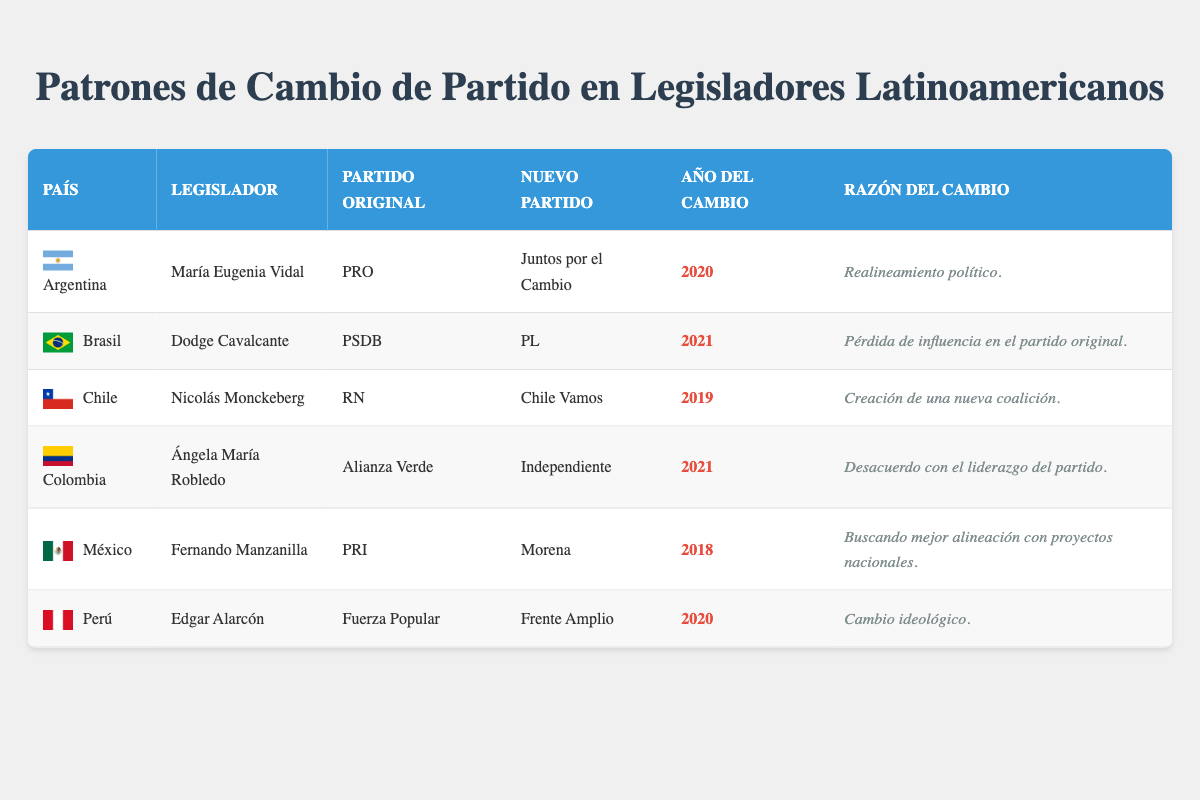What country did María Eugenia Vidal switch parties in? According to the table, María Eugenia Vidal switched parties in Argentina.
Answer: Argentina In what year did Fernando Manzanilla change parties? The table indicates that Fernando Manzanilla changed parties in the year 2018.
Answer: 2018 Which legislator switched from Alianza Verde to Independiente? From the data in the table, the legislator who switched from Alianza Verde to Independiente is Ángela María Robledo.
Answer: Ángela María Robledo How many legislators switched parties for reasons related to political realignment? There is only one legislator, María Eugenia Vidal, who switched parties for the reason of political realignment, as noted in the "reason for switch" column.
Answer: 1 Was Nicolás Monckeberg's switch related to disagreement with party leadership? The table states that Nicolás Monckeberg's switch was due to the creation of a new coalition, not disagreement with party leadership. Thus, the answer is no.
Answer: No What is the average year of party switch among the listed legislators? To find the average year, we add the years of switch (2020, 2021, 2019, 2021, 2018, 2020 = 2019) and divide by the number of legislators (6): (2020 + 2021 + 2019 + 2021 + 2018 + 2020) / 6 = 2019.
Answer: 2019 Which party did Dodge Cavalcante join after leaving PSDB? The table shows that Dodge Cavalcante joined the PL after leaving PSDB.
Answer: PL Is it true that all legislators switched to parties that were established coalitions? Not all legislators switched to parties that were established coalitions; Edgar Alarcón switched to Frente Amplio, which might be considered a coalition, but the context should be assessed for others. Therefore, the answer is no.
Answer: No What is the primary reason for Edgar Alarcón's party switch? According to the table, Edgar Alarcón switched for the reason of an ideological shift, as mentioned in the "reason for switch" column.
Answer: Cambio ideológico 